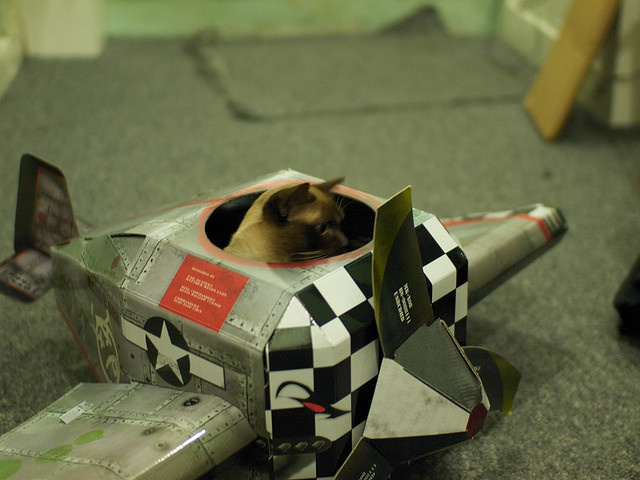Describe the objects in this image and their specific colors. I can see airplane in olive, black, and darkgreen tones and cat in olive and black tones in this image. 